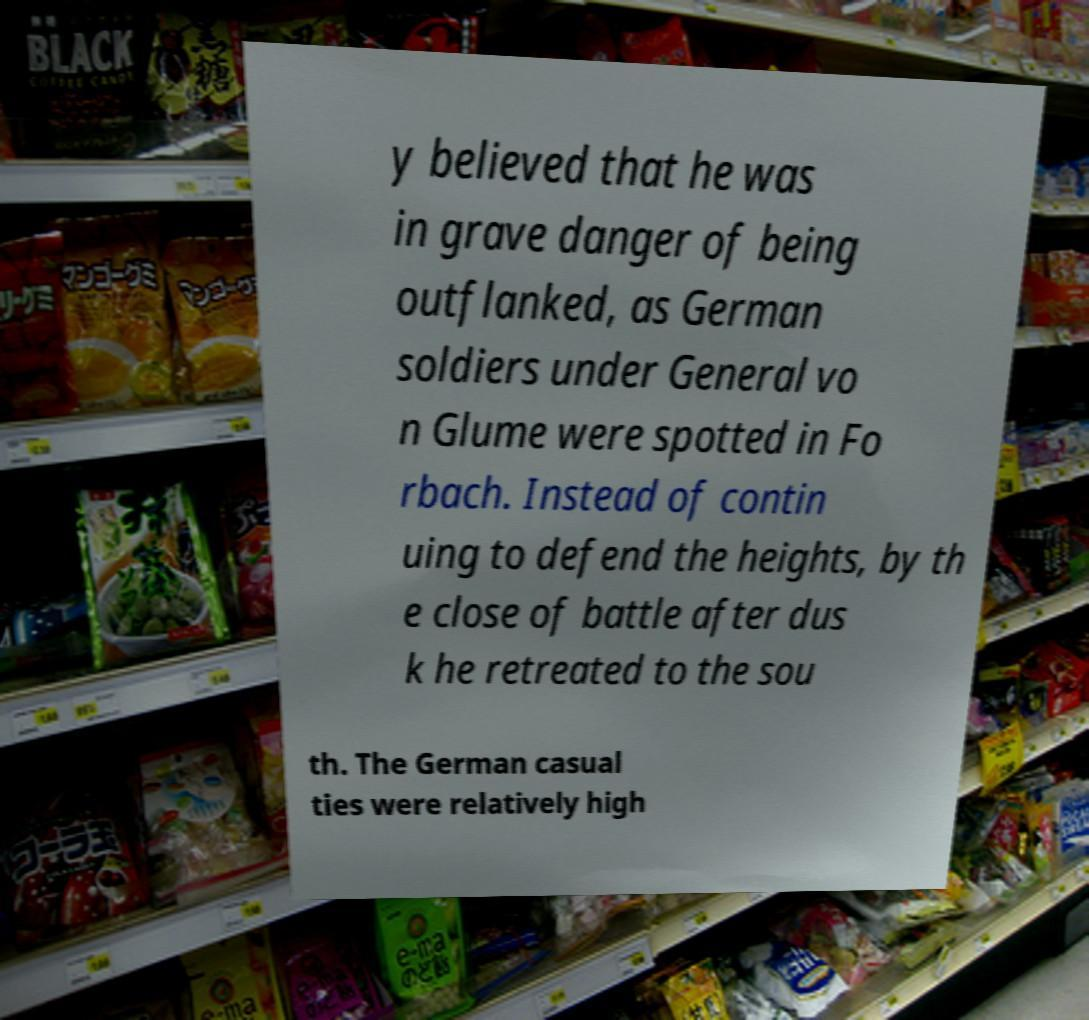Could you assist in decoding the text presented in this image and type it out clearly? y believed that he was in grave danger of being outflanked, as German soldiers under General vo n Glume were spotted in Fo rbach. Instead of contin uing to defend the heights, by th e close of battle after dus k he retreated to the sou th. The German casual ties were relatively high 